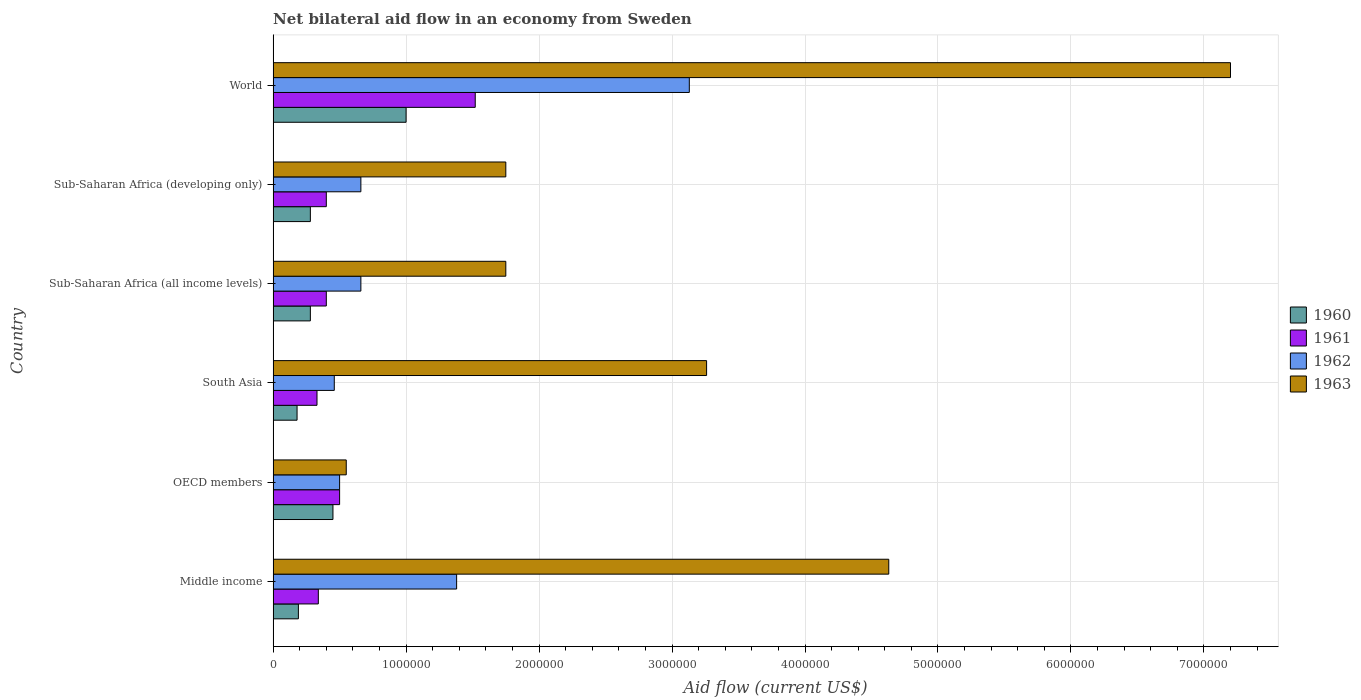How many different coloured bars are there?
Give a very brief answer. 4. How many groups of bars are there?
Give a very brief answer. 6. Are the number of bars per tick equal to the number of legend labels?
Provide a short and direct response. Yes. Are the number of bars on each tick of the Y-axis equal?
Your answer should be compact. Yes. How many bars are there on the 2nd tick from the bottom?
Ensure brevity in your answer.  4. What is the label of the 3rd group of bars from the top?
Keep it short and to the point. Sub-Saharan Africa (all income levels). In how many cases, is the number of bars for a given country not equal to the number of legend labels?
Provide a succinct answer. 0. What is the net bilateral aid flow in 1963 in South Asia?
Ensure brevity in your answer.  3.26e+06. In which country was the net bilateral aid flow in 1962 minimum?
Give a very brief answer. South Asia. What is the total net bilateral aid flow in 1963 in the graph?
Offer a terse response. 1.91e+07. What is the difference between the net bilateral aid flow in 1961 in South Asia and that in World?
Ensure brevity in your answer.  -1.19e+06. What is the difference between the net bilateral aid flow in 1961 in South Asia and the net bilateral aid flow in 1963 in Sub-Saharan Africa (all income levels)?
Offer a terse response. -1.42e+06. What is the average net bilateral aid flow in 1963 per country?
Your answer should be compact. 3.19e+06. What is the difference between the net bilateral aid flow in 1963 and net bilateral aid flow in 1962 in World?
Provide a short and direct response. 4.07e+06. What is the ratio of the net bilateral aid flow in 1960 in Sub-Saharan Africa (developing only) to that in World?
Give a very brief answer. 0.28. Is the net bilateral aid flow in 1960 in OECD members less than that in Sub-Saharan Africa (developing only)?
Your answer should be compact. No. What is the difference between the highest and the second highest net bilateral aid flow in 1963?
Your response must be concise. 2.57e+06. What is the difference between the highest and the lowest net bilateral aid flow in 1962?
Give a very brief answer. 2.67e+06. In how many countries, is the net bilateral aid flow in 1960 greater than the average net bilateral aid flow in 1960 taken over all countries?
Provide a short and direct response. 2. Is the sum of the net bilateral aid flow in 1960 in Sub-Saharan Africa (all income levels) and Sub-Saharan Africa (developing only) greater than the maximum net bilateral aid flow in 1962 across all countries?
Your answer should be compact. No. Is it the case that in every country, the sum of the net bilateral aid flow in 1962 and net bilateral aid flow in 1960 is greater than the sum of net bilateral aid flow in 1961 and net bilateral aid flow in 1963?
Keep it short and to the point. No. What does the 1st bar from the top in World represents?
Keep it short and to the point. 1963. What does the 4th bar from the bottom in South Asia represents?
Offer a very short reply. 1963. Are the values on the major ticks of X-axis written in scientific E-notation?
Ensure brevity in your answer.  No. Where does the legend appear in the graph?
Give a very brief answer. Center right. How many legend labels are there?
Offer a very short reply. 4. What is the title of the graph?
Offer a terse response. Net bilateral aid flow in an economy from Sweden. Does "1996" appear as one of the legend labels in the graph?
Ensure brevity in your answer.  No. What is the label or title of the X-axis?
Give a very brief answer. Aid flow (current US$). What is the Aid flow (current US$) of 1962 in Middle income?
Provide a succinct answer. 1.38e+06. What is the Aid flow (current US$) in 1963 in Middle income?
Offer a very short reply. 4.63e+06. What is the Aid flow (current US$) of 1962 in OECD members?
Your response must be concise. 5.00e+05. What is the Aid flow (current US$) in 1961 in South Asia?
Ensure brevity in your answer.  3.30e+05. What is the Aid flow (current US$) of 1962 in South Asia?
Ensure brevity in your answer.  4.60e+05. What is the Aid flow (current US$) in 1963 in South Asia?
Make the answer very short. 3.26e+06. What is the Aid flow (current US$) of 1962 in Sub-Saharan Africa (all income levels)?
Give a very brief answer. 6.60e+05. What is the Aid flow (current US$) of 1963 in Sub-Saharan Africa (all income levels)?
Keep it short and to the point. 1.75e+06. What is the Aid flow (current US$) of 1961 in Sub-Saharan Africa (developing only)?
Give a very brief answer. 4.00e+05. What is the Aid flow (current US$) of 1962 in Sub-Saharan Africa (developing only)?
Keep it short and to the point. 6.60e+05. What is the Aid flow (current US$) of 1963 in Sub-Saharan Africa (developing only)?
Offer a terse response. 1.75e+06. What is the Aid flow (current US$) in 1961 in World?
Give a very brief answer. 1.52e+06. What is the Aid flow (current US$) in 1962 in World?
Your answer should be compact. 3.13e+06. What is the Aid flow (current US$) in 1963 in World?
Provide a succinct answer. 7.20e+06. Across all countries, what is the maximum Aid flow (current US$) in 1961?
Keep it short and to the point. 1.52e+06. Across all countries, what is the maximum Aid flow (current US$) of 1962?
Ensure brevity in your answer.  3.13e+06. Across all countries, what is the maximum Aid flow (current US$) in 1963?
Offer a terse response. 7.20e+06. Across all countries, what is the minimum Aid flow (current US$) of 1962?
Offer a very short reply. 4.60e+05. Across all countries, what is the minimum Aid flow (current US$) in 1963?
Ensure brevity in your answer.  5.50e+05. What is the total Aid flow (current US$) of 1960 in the graph?
Provide a succinct answer. 2.38e+06. What is the total Aid flow (current US$) of 1961 in the graph?
Provide a short and direct response. 3.49e+06. What is the total Aid flow (current US$) in 1962 in the graph?
Your answer should be compact. 6.79e+06. What is the total Aid flow (current US$) of 1963 in the graph?
Your answer should be compact. 1.91e+07. What is the difference between the Aid flow (current US$) in 1962 in Middle income and that in OECD members?
Keep it short and to the point. 8.80e+05. What is the difference between the Aid flow (current US$) of 1963 in Middle income and that in OECD members?
Provide a succinct answer. 4.08e+06. What is the difference between the Aid flow (current US$) of 1960 in Middle income and that in South Asia?
Ensure brevity in your answer.  10000. What is the difference between the Aid flow (current US$) of 1962 in Middle income and that in South Asia?
Ensure brevity in your answer.  9.20e+05. What is the difference between the Aid flow (current US$) of 1963 in Middle income and that in South Asia?
Ensure brevity in your answer.  1.37e+06. What is the difference between the Aid flow (current US$) in 1960 in Middle income and that in Sub-Saharan Africa (all income levels)?
Keep it short and to the point. -9.00e+04. What is the difference between the Aid flow (current US$) of 1962 in Middle income and that in Sub-Saharan Africa (all income levels)?
Keep it short and to the point. 7.20e+05. What is the difference between the Aid flow (current US$) in 1963 in Middle income and that in Sub-Saharan Africa (all income levels)?
Ensure brevity in your answer.  2.88e+06. What is the difference between the Aid flow (current US$) of 1960 in Middle income and that in Sub-Saharan Africa (developing only)?
Your answer should be very brief. -9.00e+04. What is the difference between the Aid flow (current US$) of 1962 in Middle income and that in Sub-Saharan Africa (developing only)?
Give a very brief answer. 7.20e+05. What is the difference between the Aid flow (current US$) in 1963 in Middle income and that in Sub-Saharan Africa (developing only)?
Offer a very short reply. 2.88e+06. What is the difference between the Aid flow (current US$) of 1960 in Middle income and that in World?
Offer a terse response. -8.10e+05. What is the difference between the Aid flow (current US$) of 1961 in Middle income and that in World?
Your answer should be very brief. -1.18e+06. What is the difference between the Aid flow (current US$) in 1962 in Middle income and that in World?
Your response must be concise. -1.75e+06. What is the difference between the Aid flow (current US$) in 1963 in Middle income and that in World?
Your answer should be very brief. -2.57e+06. What is the difference between the Aid flow (current US$) in 1962 in OECD members and that in South Asia?
Make the answer very short. 4.00e+04. What is the difference between the Aid flow (current US$) in 1963 in OECD members and that in South Asia?
Offer a terse response. -2.71e+06. What is the difference between the Aid flow (current US$) in 1960 in OECD members and that in Sub-Saharan Africa (all income levels)?
Your answer should be compact. 1.70e+05. What is the difference between the Aid flow (current US$) of 1961 in OECD members and that in Sub-Saharan Africa (all income levels)?
Your answer should be compact. 1.00e+05. What is the difference between the Aid flow (current US$) in 1962 in OECD members and that in Sub-Saharan Africa (all income levels)?
Provide a succinct answer. -1.60e+05. What is the difference between the Aid flow (current US$) of 1963 in OECD members and that in Sub-Saharan Africa (all income levels)?
Ensure brevity in your answer.  -1.20e+06. What is the difference between the Aid flow (current US$) of 1962 in OECD members and that in Sub-Saharan Africa (developing only)?
Provide a short and direct response. -1.60e+05. What is the difference between the Aid flow (current US$) of 1963 in OECD members and that in Sub-Saharan Africa (developing only)?
Keep it short and to the point. -1.20e+06. What is the difference between the Aid flow (current US$) in 1960 in OECD members and that in World?
Your answer should be compact. -5.50e+05. What is the difference between the Aid flow (current US$) of 1961 in OECD members and that in World?
Your response must be concise. -1.02e+06. What is the difference between the Aid flow (current US$) of 1962 in OECD members and that in World?
Provide a short and direct response. -2.63e+06. What is the difference between the Aid flow (current US$) of 1963 in OECD members and that in World?
Give a very brief answer. -6.65e+06. What is the difference between the Aid flow (current US$) in 1962 in South Asia and that in Sub-Saharan Africa (all income levels)?
Keep it short and to the point. -2.00e+05. What is the difference between the Aid flow (current US$) in 1963 in South Asia and that in Sub-Saharan Africa (all income levels)?
Keep it short and to the point. 1.51e+06. What is the difference between the Aid flow (current US$) in 1960 in South Asia and that in Sub-Saharan Africa (developing only)?
Provide a short and direct response. -1.00e+05. What is the difference between the Aid flow (current US$) of 1962 in South Asia and that in Sub-Saharan Africa (developing only)?
Your answer should be compact. -2.00e+05. What is the difference between the Aid flow (current US$) in 1963 in South Asia and that in Sub-Saharan Africa (developing only)?
Keep it short and to the point. 1.51e+06. What is the difference between the Aid flow (current US$) of 1960 in South Asia and that in World?
Your answer should be very brief. -8.20e+05. What is the difference between the Aid flow (current US$) of 1961 in South Asia and that in World?
Provide a short and direct response. -1.19e+06. What is the difference between the Aid flow (current US$) of 1962 in South Asia and that in World?
Offer a terse response. -2.67e+06. What is the difference between the Aid flow (current US$) of 1963 in South Asia and that in World?
Your answer should be compact. -3.94e+06. What is the difference between the Aid flow (current US$) of 1962 in Sub-Saharan Africa (all income levels) and that in Sub-Saharan Africa (developing only)?
Provide a succinct answer. 0. What is the difference between the Aid flow (current US$) of 1960 in Sub-Saharan Africa (all income levels) and that in World?
Provide a succinct answer. -7.20e+05. What is the difference between the Aid flow (current US$) of 1961 in Sub-Saharan Africa (all income levels) and that in World?
Your answer should be very brief. -1.12e+06. What is the difference between the Aid flow (current US$) of 1962 in Sub-Saharan Africa (all income levels) and that in World?
Offer a very short reply. -2.47e+06. What is the difference between the Aid flow (current US$) in 1963 in Sub-Saharan Africa (all income levels) and that in World?
Ensure brevity in your answer.  -5.45e+06. What is the difference between the Aid flow (current US$) of 1960 in Sub-Saharan Africa (developing only) and that in World?
Offer a very short reply. -7.20e+05. What is the difference between the Aid flow (current US$) in 1961 in Sub-Saharan Africa (developing only) and that in World?
Make the answer very short. -1.12e+06. What is the difference between the Aid flow (current US$) in 1962 in Sub-Saharan Africa (developing only) and that in World?
Make the answer very short. -2.47e+06. What is the difference between the Aid flow (current US$) of 1963 in Sub-Saharan Africa (developing only) and that in World?
Your response must be concise. -5.45e+06. What is the difference between the Aid flow (current US$) in 1960 in Middle income and the Aid flow (current US$) in 1961 in OECD members?
Your response must be concise. -3.10e+05. What is the difference between the Aid flow (current US$) in 1960 in Middle income and the Aid flow (current US$) in 1962 in OECD members?
Give a very brief answer. -3.10e+05. What is the difference between the Aid flow (current US$) of 1960 in Middle income and the Aid flow (current US$) of 1963 in OECD members?
Ensure brevity in your answer.  -3.60e+05. What is the difference between the Aid flow (current US$) in 1961 in Middle income and the Aid flow (current US$) in 1963 in OECD members?
Your response must be concise. -2.10e+05. What is the difference between the Aid flow (current US$) of 1962 in Middle income and the Aid flow (current US$) of 1963 in OECD members?
Make the answer very short. 8.30e+05. What is the difference between the Aid flow (current US$) in 1960 in Middle income and the Aid flow (current US$) in 1961 in South Asia?
Provide a succinct answer. -1.40e+05. What is the difference between the Aid flow (current US$) of 1960 in Middle income and the Aid flow (current US$) of 1963 in South Asia?
Ensure brevity in your answer.  -3.07e+06. What is the difference between the Aid flow (current US$) in 1961 in Middle income and the Aid flow (current US$) in 1962 in South Asia?
Make the answer very short. -1.20e+05. What is the difference between the Aid flow (current US$) of 1961 in Middle income and the Aid flow (current US$) of 1963 in South Asia?
Provide a succinct answer. -2.92e+06. What is the difference between the Aid flow (current US$) of 1962 in Middle income and the Aid flow (current US$) of 1963 in South Asia?
Offer a very short reply. -1.88e+06. What is the difference between the Aid flow (current US$) in 1960 in Middle income and the Aid flow (current US$) in 1962 in Sub-Saharan Africa (all income levels)?
Your answer should be compact. -4.70e+05. What is the difference between the Aid flow (current US$) of 1960 in Middle income and the Aid flow (current US$) of 1963 in Sub-Saharan Africa (all income levels)?
Give a very brief answer. -1.56e+06. What is the difference between the Aid flow (current US$) in 1961 in Middle income and the Aid flow (current US$) in 1962 in Sub-Saharan Africa (all income levels)?
Ensure brevity in your answer.  -3.20e+05. What is the difference between the Aid flow (current US$) of 1961 in Middle income and the Aid flow (current US$) of 1963 in Sub-Saharan Africa (all income levels)?
Your response must be concise. -1.41e+06. What is the difference between the Aid flow (current US$) of 1962 in Middle income and the Aid flow (current US$) of 1963 in Sub-Saharan Africa (all income levels)?
Ensure brevity in your answer.  -3.70e+05. What is the difference between the Aid flow (current US$) of 1960 in Middle income and the Aid flow (current US$) of 1961 in Sub-Saharan Africa (developing only)?
Your response must be concise. -2.10e+05. What is the difference between the Aid flow (current US$) of 1960 in Middle income and the Aid flow (current US$) of 1962 in Sub-Saharan Africa (developing only)?
Keep it short and to the point. -4.70e+05. What is the difference between the Aid flow (current US$) in 1960 in Middle income and the Aid flow (current US$) in 1963 in Sub-Saharan Africa (developing only)?
Provide a short and direct response. -1.56e+06. What is the difference between the Aid flow (current US$) of 1961 in Middle income and the Aid flow (current US$) of 1962 in Sub-Saharan Africa (developing only)?
Keep it short and to the point. -3.20e+05. What is the difference between the Aid flow (current US$) of 1961 in Middle income and the Aid flow (current US$) of 1963 in Sub-Saharan Africa (developing only)?
Your response must be concise. -1.41e+06. What is the difference between the Aid flow (current US$) in 1962 in Middle income and the Aid flow (current US$) in 1963 in Sub-Saharan Africa (developing only)?
Your response must be concise. -3.70e+05. What is the difference between the Aid flow (current US$) of 1960 in Middle income and the Aid flow (current US$) of 1961 in World?
Your answer should be very brief. -1.33e+06. What is the difference between the Aid flow (current US$) of 1960 in Middle income and the Aid flow (current US$) of 1962 in World?
Provide a succinct answer. -2.94e+06. What is the difference between the Aid flow (current US$) of 1960 in Middle income and the Aid flow (current US$) of 1963 in World?
Provide a succinct answer. -7.01e+06. What is the difference between the Aid flow (current US$) of 1961 in Middle income and the Aid flow (current US$) of 1962 in World?
Provide a short and direct response. -2.79e+06. What is the difference between the Aid flow (current US$) of 1961 in Middle income and the Aid flow (current US$) of 1963 in World?
Ensure brevity in your answer.  -6.86e+06. What is the difference between the Aid flow (current US$) of 1962 in Middle income and the Aid flow (current US$) of 1963 in World?
Offer a terse response. -5.82e+06. What is the difference between the Aid flow (current US$) in 1960 in OECD members and the Aid flow (current US$) in 1961 in South Asia?
Your answer should be very brief. 1.20e+05. What is the difference between the Aid flow (current US$) of 1960 in OECD members and the Aid flow (current US$) of 1962 in South Asia?
Provide a short and direct response. -10000. What is the difference between the Aid flow (current US$) of 1960 in OECD members and the Aid flow (current US$) of 1963 in South Asia?
Give a very brief answer. -2.81e+06. What is the difference between the Aid flow (current US$) of 1961 in OECD members and the Aid flow (current US$) of 1962 in South Asia?
Your response must be concise. 4.00e+04. What is the difference between the Aid flow (current US$) of 1961 in OECD members and the Aid flow (current US$) of 1963 in South Asia?
Ensure brevity in your answer.  -2.76e+06. What is the difference between the Aid flow (current US$) of 1962 in OECD members and the Aid flow (current US$) of 1963 in South Asia?
Your response must be concise. -2.76e+06. What is the difference between the Aid flow (current US$) in 1960 in OECD members and the Aid flow (current US$) in 1961 in Sub-Saharan Africa (all income levels)?
Provide a short and direct response. 5.00e+04. What is the difference between the Aid flow (current US$) of 1960 in OECD members and the Aid flow (current US$) of 1963 in Sub-Saharan Africa (all income levels)?
Provide a short and direct response. -1.30e+06. What is the difference between the Aid flow (current US$) of 1961 in OECD members and the Aid flow (current US$) of 1963 in Sub-Saharan Africa (all income levels)?
Offer a very short reply. -1.25e+06. What is the difference between the Aid flow (current US$) of 1962 in OECD members and the Aid flow (current US$) of 1963 in Sub-Saharan Africa (all income levels)?
Provide a succinct answer. -1.25e+06. What is the difference between the Aid flow (current US$) of 1960 in OECD members and the Aid flow (current US$) of 1961 in Sub-Saharan Africa (developing only)?
Keep it short and to the point. 5.00e+04. What is the difference between the Aid flow (current US$) in 1960 in OECD members and the Aid flow (current US$) in 1963 in Sub-Saharan Africa (developing only)?
Offer a terse response. -1.30e+06. What is the difference between the Aid flow (current US$) in 1961 in OECD members and the Aid flow (current US$) in 1962 in Sub-Saharan Africa (developing only)?
Your answer should be compact. -1.60e+05. What is the difference between the Aid flow (current US$) in 1961 in OECD members and the Aid flow (current US$) in 1963 in Sub-Saharan Africa (developing only)?
Provide a succinct answer. -1.25e+06. What is the difference between the Aid flow (current US$) of 1962 in OECD members and the Aid flow (current US$) of 1963 in Sub-Saharan Africa (developing only)?
Your answer should be compact. -1.25e+06. What is the difference between the Aid flow (current US$) in 1960 in OECD members and the Aid flow (current US$) in 1961 in World?
Offer a very short reply. -1.07e+06. What is the difference between the Aid flow (current US$) of 1960 in OECD members and the Aid flow (current US$) of 1962 in World?
Your answer should be compact. -2.68e+06. What is the difference between the Aid flow (current US$) in 1960 in OECD members and the Aid flow (current US$) in 1963 in World?
Ensure brevity in your answer.  -6.75e+06. What is the difference between the Aid flow (current US$) in 1961 in OECD members and the Aid flow (current US$) in 1962 in World?
Give a very brief answer. -2.63e+06. What is the difference between the Aid flow (current US$) in 1961 in OECD members and the Aid flow (current US$) in 1963 in World?
Offer a very short reply. -6.70e+06. What is the difference between the Aid flow (current US$) in 1962 in OECD members and the Aid flow (current US$) in 1963 in World?
Your answer should be compact. -6.70e+06. What is the difference between the Aid flow (current US$) in 1960 in South Asia and the Aid flow (current US$) in 1962 in Sub-Saharan Africa (all income levels)?
Your response must be concise. -4.80e+05. What is the difference between the Aid flow (current US$) of 1960 in South Asia and the Aid flow (current US$) of 1963 in Sub-Saharan Africa (all income levels)?
Provide a short and direct response. -1.57e+06. What is the difference between the Aid flow (current US$) of 1961 in South Asia and the Aid flow (current US$) of 1962 in Sub-Saharan Africa (all income levels)?
Your answer should be very brief. -3.30e+05. What is the difference between the Aid flow (current US$) in 1961 in South Asia and the Aid flow (current US$) in 1963 in Sub-Saharan Africa (all income levels)?
Offer a terse response. -1.42e+06. What is the difference between the Aid flow (current US$) in 1962 in South Asia and the Aid flow (current US$) in 1963 in Sub-Saharan Africa (all income levels)?
Your response must be concise. -1.29e+06. What is the difference between the Aid flow (current US$) of 1960 in South Asia and the Aid flow (current US$) of 1962 in Sub-Saharan Africa (developing only)?
Your response must be concise. -4.80e+05. What is the difference between the Aid flow (current US$) of 1960 in South Asia and the Aid flow (current US$) of 1963 in Sub-Saharan Africa (developing only)?
Ensure brevity in your answer.  -1.57e+06. What is the difference between the Aid flow (current US$) in 1961 in South Asia and the Aid flow (current US$) in 1962 in Sub-Saharan Africa (developing only)?
Make the answer very short. -3.30e+05. What is the difference between the Aid flow (current US$) in 1961 in South Asia and the Aid flow (current US$) in 1963 in Sub-Saharan Africa (developing only)?
Your answer should be compact. -1.42e+06. What is the difference between the Aid flow (current US$) in 1962 in South Asia and the Aid flow (current US$) in 1963 in Sub-Saharan Africa (developing only)?
Offer a very short reply. -1.29e+06. What is the difference between the Aid flow (current US$) of 1960 in South Asia and the Aid flow (current US$) of 1961 in World?
Your answer should be very brief. -1.34e+06. What is the difference between the Aid flow (current US$) of 1960 in South Asia and the Aid flow (current US$) of 1962 in World?
Ensure brevity in your answer.  -2.95e+06. What is the difference between the Aid flow (current US$) in 1960 in South Asia and the Aid flow (current US$) in 1963 in World?
Provide a succinct answer. -7.02e+06. What is the difference between the Aid flow (current US$) of 1961 in South Asia and the Aid flow (current US$) of 1962 in World?
Your answer should be compact. -2.80e+06. What is the difference between the Aid flow (current US$) of 1961 in South Asia and the Aid flow (current US$) of 1963 in World?
Your response must be concise. -6.87e+06. What is the difference between the Aid flow (current US$) in 1962 in South Asia and the Aid flow (current US$) in 1963 in World?
Provide a short and direct response. -6.74e+06. What is the difference between the Aid flow (current US$) of 1960 in Sub-Saharan Africa (all income levels) and the Aid flow (current US$) of 1961 in Sub-Saharan Africa (developing only)?
Make the answer very short. -1.20e+05. What is the difference between the Aid flow (current US$) of 1960 in Sub-Saharan Africa (all income levels) and the Aid flow (current US$) of 1962 in Sub-Saharan Africa (developing only)?
Make the answer very short. -3.80e+05. What is the difference between the Aid flow (current US$) in 1960 in Sub-Saharan Africa (all income levels) and the Aid flow (current US$) in 1963 in Sub-Saharan Africa (developing only)?
Your answer should be very brief. -1.47e+06. What is the difference between the Aid flow (current US$) of 1961 in Sub-Saharan Africa (all income levels) and the Aid flow (current US$) of 1962 in Sub-Saharan Africa (developing only)?
Your answer should be compact. -2.60e+05. What is the difference between the Aid flow (current US$) of 1961 in Sub-Saharan Africa (all income levels) and the Aid flow (current US$) of 1963 in Sub-Saharan Africa (developing only)?
Offer a very short reply. -1.35e+06. What is the difference between the Aid flow (current US$) in 1962 in Sub-Saharan Africa (all income levels) and the Aid flow (current US$) in 1963 in Sub-Saharan Africa (developing only)?
Offer a very short reply. -1.09e+06. What is the difference between the Aid flow (current US$) of 1960 in Sub-Saharan Africa (all income levels) and the Aid flow (current US$) of 1961 in World?
Your answer should be very brief. -1.24e+06. What is the difference between the Aid flow (current US$) of 1960 in Sub-Saharan Africa (all income levels) and the Aid flow (current US$) of 1962 in World?
Ensure brevity in your answer.  -2.85e+06. What is the difference between the Aid flow (current US$) of 1960 in Sub-Saharan Africa (all income levels) and the Aid flow (current US$) of 1963 in World?
Your answer should be compact. -6.92e+06. What is the difference between the Aid flow (current US$) of 1961 in Sub-Saharan Africa (all income levels) and the Aid flow (current US$) of 1962 in World?
Your response must be concise. -2.73e+06. What is the difference between the Aid flow (current US$) of 1961 in Sub-Saharan Africa (all income levels) and the Aid flow (current US$) of 1963 in World?
Provide a short and direct response. -6.80e+06. What is the difference between the Aid flow (current US$) in 1962 in Sub-Saharan Africa (all income levels) and the Aid flow (current US$) in 1963 in World?
Ensure brevity in your answer.  -6.54e+06. What is the difference between the Aid flow (current US$) of 1960 in Sub-Saharan Africa (developing only) and the Aid flow (current US$) of 1961 in World?
Provide a short and direct response. -1.24e+06. What is the difference between the Aid flow (current US$) of 1960 in Sub-Saharan Africa (developing only) and the Aid flow (current US$) of 1962 in World?
Your response must be concise. -2.85e+06. What is the difference between the Aid flow (current US$) of 1960 in Sub-Saharan Africa (developing only) and the Aid flow (current US$) of 1963 in World?
Make the answer very short. -6.92e+06. What is the difference between the Aid flow (current US$) of 1961 in Sub-Saharan Africa (developing only) and the Aid flow (current US$) of 1962 in World?
Your answer should be compact. -2.73e+06. What is the difference between the Aid flow (current US$) in 1961 in Sub-Saharan Africa (developing only) and the Aid flow (current US$) in 1963 in World?
Make the answer very short. -6.80e+06. What is the difference between the Aid flow (current US$) in 1962 in Sub-Saharan Africa (developing only) and the Aid flow (current US$) in 1963 in World?
Your answer should be very brief. -6.54e+06. What is the average Aid flow (current US$) in 1960 per country?
Ensure brevity in your answer.  3.97e+05. What is the average Aid flow (current US$) of 1961 per country?
Your answer should be very brief. 5.82e+05. What is the average Aid flow (current US$) in 1962 per country?
Provide a short and direct response. 1.13e+06. What is the average Aid flow (current US$) of 1963 per country?
Your answer should be compact. 3.19e+06. What is the difference between the Aid flow (current US$) in 1960 and Aid flow (current US$) in 1961 in Middle income?
Provide a short and direct response. -1.50e+05. What is the difference between the Aid flow (current US$) of 1960 and Aid flow (current US$) of 1962 in Middle income?
Provide a succinct answer. -1.19e+06. What is the difference between the Aid flow (current US$) in 1960 and Aid flow (current US$) in 1963 in Middle income?
Provide a short and direct response. -4.44e+06. What is the difference between the Aid flow (current US$) of 1961 and Aid flow (current US$) of 1962 in Middle income?
Give a very brief answer. -1.04e+06. What is the difference between the Aid flow (current US$) in 1961 and Aid flow (current US$) in 1963 in Middle income?
Offer a very short reply. -4.29e+06. What is the difference between the Aid flow (current US$) in 1962 and Aid flow (current US$) in 1963 in Middle income?
Offer a very short reply. -3.25e+06. What is the difference between the Aid flow (current US$) in 1960 and Aid flow (current US$) in 1962 in OECD members?
Give a very brief answer. -5.00e+04. What is the difference between the Aid flow (current US$) of 1960 and Aid flow (current US$) of 1963 in OECD members?
Give a very brief answer. -1.00e+05. What is the difference between the Aid flow (current US$) of 1960 and Aid flow (current US$) of 1961 in South Asia?
Your answer should be very brief. -1.50e+05. What is the difference between the Aid flow (current US$) in 1960 and Aid flow (current US$) in 1962 in South Asia?
Keep it short and to the point. -2.80e+05. What is the difference between the Aid flow (current US$) in 1960 and Aid flow (current US$) in 1963 in South Asia?
Your response must be concise. -3.08e+06. What is the difference between the Aid flow (current US$) in 1961 and Aid flow (current US$) in 1963 in South Asia?
Offer a terse response. -2.93e+06. What is the difference between the Aid flow (current US$) of 1962 and Aid flow (current US$) of 1963 in South Asia?
Offer a very short reply. -2.80e+06. What is the difference between the Aid flow (current US$) of 1960 and Aid flow (current US$) of 1961 in Sub-Saharan Africa (all income levels)?
Give a very brief answer. -1.20e+05. What is the difference between the Aid flow (current US$) of 1960 and Aid flow (current US$) of 1962 in Sub-Saharan Africa (all income levels)?
Offer a very short reply. -3.80e+05. What is the difference between the Aid flow (current US$) of 1960 and Aid flow (current US$) of 1963 in Sub-Saharan Africa (all income levels)?
Ensure brevity in your answer.  -1.47e+06. What is the difference between the Aid flow (current US$) of 1961 and Aid flow (current US$) of 1963 in Sub-Saharan Africa (all income levels)?
Make the answer very short. -1.35e+06. What is the difference between the Aid flow (current US$) in 1962 and Aid flow (current US$) in 1963 in Sub-Saharan Africa (all income levels)?
Offer a terse response. -1.09e+06. What is the difference between the Aid flow (current US$) in 1960 and Aid flow (current US$) in 1961 in Sub-Saharan Africa (developing only)?
Your answer should be compact. -1.20e+05. What is the difference between the Aid flow (current US$) in 1960 and Aid flow (current US$) in 1962 in Sub-Saharan Africa (developing only)?
Offer a very short reply. -3.80e+05. What is the difference between the Aid flow (current US$) of 1960 and Aid flow (current US$) of 1963 in Sub-Saharan Africa (developing only)?
Keep it short and to the point. -1.47e+06. What is the difference between the Aid flow (current US$) of 1961 and Aid flow (current US$) of 1963 in Sub-Saharan Africa (developing only)?
Give a very brief answer. -1.35e+06. What is the difference between the Aid flow (current US$) in 1962 and Aid flow (current US$) in 1963 in Sub-Saharan Africa (developing only)?
Make the answer very short. -1.09e+06. What is the difference between the Aid flow (current US$) in 1960 and Aid flow (current US$) in 1961 in World?
Make the answer very short. -5.20e+05. What is the difference between the Aid flow (current US$) in 1960 and Aid flow (current US$) in 1962 in World?
Make the answer very short. -2.13e+06. What is the difference between the Aid flow (current US$) of 1960 and Aid flow (current US$) of 1963 in World?
Your response must be concise. -6.20e+06. What is the difference between the Aid flow (current US$) in 1961 and Aid flow (current US$) in 1962 in World?
Keep it short and to the point. -1.61e+06. What is the difference between the Aid flow (current US$) of 1961 and Aid flow (current US$) of 1963 in World?
Your answer should be very brief. -5.68e+06. What is the difference between the Aid flow (current US$) of 1962 and Aid flow (current US$) of 1963 in World?
Give a very brief answer. -4.07e+06. What is the ratio of the Aid flow (current US$) in 1960 in Middle income to that in OECD members?
Offer a terse response. 0.42. What is the ratio of the Aid flow (current US$) in 1961 in Middle income to that in OECD members?
Give a very brief answer. 0.68. What is the ratio of the Aid flow (current US$) in 1962 in Middle income to that in OECD members?
Provide a short and direct response. 2.76. What is the ratio of the Aid flow (current US$) of 1963 in Middle income to that in OECD members?
Provide a short and direct response. 8.42. What is the ratio of the Aid flow (current US$) in 1960 in Middle income to that in South Asia?
Ensure brevity in your answer.  1.06. What is the ratio of the Aid flow (current US$) of 1961 in Middle income to that in South Asia?
Provide a succinct answer. 1.03. What is the ratio of the Aid flow (current US$) of 1963 in Middle income to that in South Asia?
Offer a very short reply. 1.42. What is the ratio of the Aid flow (current US$) of 1960 in Middle income to that in Sub-Saharan Africa (all income levels)?
Give a very brief answer. 0.68. What is the ratio of the Aid flow (current US$) of 1962 in Middle income to that in Sub-Saharan Africa (all income levels)?
Provide a succinct answer. 2.09. What is the ratio of the Aid flow (current US$) in 1963 in Middle income to that in Sub-Saharan Africa (all income levels)?
Ensure brevity in your answer.  2.65. What is the ratio of the Aid flow (current US$) of 1960 in Middle income to that in Sub-Saharan Africa (developing only)?
Offer a very short reply. 0.68. What is the ratio of the Aid flow (current US$) in 1962 in Middle income to that in Sub-Saharan Africa (developing only)?
Provide a short and direct response. 2.09. What is the ratio of the Aid flow (current US$) of 1963 in Middle income to that in Sub-Saharan Africa (developing only)?
Give a very brief answer. 2.65. What is the ratio of the Aid flow (current US$) of 1960 in Middle income to that in World?
Your response must be concise. 0.19. What is the ratio of the Aid flow (current US$) in 1961 in Middle income to that in World?
Offer a very short reply. 0.22. What is the ratio of the Aid flow (current US$) in 1962 in Middle income to that in World?
Your answer should be compact. 0.44. What is the ratio of the Aid flow (current US$) in 1963 in Middle income to that in World?
Your answer should be compact. 0.64. What is the ratio of the Aid flow (current US$) of 1961 in OECD members to that in South Asia?
Make the answer very short. 1.52. What is the ratio of the Aid flow (current US$) of 1962 in OECD members to that in South Asia?
Your answer should be very brief. 1.09. What is the ratio of the Aid flow (current US$) in 1963 in OECD members to that in South Asia?
Offer a very short reply. 0.17. What is the ratio of the Aid flow (current US$) of 1960 in OECD members to that in Sub-Saharan Africa (all income levels)?
Provide a short and direct response. 1.61. What is the ratio of the Aid flow (current US$) in 1962 in OECD members to that in Sub-Saharan Africa (all income levels)?
Offer a terse response. 0.76. What is the ratio of the Aid flow (current US$) in 1963 in OECD members to that in Sub-Saharan Africa (all income levels)?
Offer a very short reply. 0.31. What is the ratio of the Aid flow (current US$) of 1960 in OECD members to that in Sub-Saharan Africa (developing only)?
Offer a very short reply. 1.61. What is the ratio of the Aid flow (current US$) of 1962 in OECD members to that in Sub-Saharan Africa (developing only)?
Provide a succinct answer. 0.76. What is the ratio of the Aid flow (current US$) of 1963 in OECD members to that in Sub-Saharan Africa (developing only)?
Ensure brevity in your answer.  0.31. What is the ratio of the Aid flow (current US$) in 1960 in OECD members to that in World?
Your answer should be compact. 0.45. What is the ratio of the Aid flow (current US$) of 1961 in OECD members to that in World?
Keep it short and to the point. 0.33. What is the ratio of the Aid flow (current US$) in 1962 in OECD members to that in World?
Offer a very short reply. 0.16. What is the ratio of the Aid flow (current US$) in 1963 in OECD members to that in World?
Offer a terse response. 0.08. What is the ratio of the Aid flow (current US$) of 1960 in South Asia to that in Sub-Saharan Africa (all income levels)?
Keep it short and to the point. 0.64. What is the ratio of the Aid flow (current US$) of 1961 in South Asia to that in Sub-Saharan Africa (all income levels)?
Offer a very short reply. 0.82. What is the ratio of the Aid flow (current US$) in 1962 in South Asia to that in Sub-Saharan Africa (all income levels)?
Your answer should be very brief. 0.7. What is the ratio of the Aid flow (current US$) of 1963 in South Asia to that in Sub-Saharan Africa (all income levels)?
Give a very brief answer. 1.86. What is the ratio of the Aid flow (current US$) in 1960 in South Asia to that in Sub-Saharan Africa (developing only)?
Your answer should be very brief. 0.64. What is the ratio of the Aid flow (current US$) in 1961 in South Asia to that in Sub-Saharan Africa (developing only)?
Provide a succinct answer. 0.82. What is the ratio of the Aid flow (current US$) in 1962 in South Asia to that in Sub-Saharan Africa (developing only)?
Offer a terse response. 0.7. What is the ratio of the Aid flow (current US$) in 1963 in South Asia to that in Sub-Saharan Africa (developing only)?
Offer a terse response. 1.86. What is the ratio of the Aid flow (current US$) in 1960 in South Asia to that in World?
Provide a succinct answer. 0.18. What is the ratio of the Aid flow (current US$) in 1961 in South Asia to that in World?
Your response must be concise. 0.22. What is the ratio of the Aid flow (current US$) in 1962 in South Asia to that in World?
Offer a very short reply. 0.15. What is the ratio of the Aid flow (current US$) in 1963 in South Asia to that in World?
Provide a short and direct response. 0.45. What is the ratio of the Aid flow (current US$) of 1961 in Sub-Saharan Africa (all income levels) to that in Sub-Saharan Africa (developing only)?
Offer a terse response. 1. What is the ratio of the Aid flow (current US$) of 1960 in Sub-Saharan Africa (all income levels) to that in World?
Offer a terse response. 0.28. What is the ratio of the Aid flow (current US$) in 1961 in Sub-Saharan Africa (all income levels) to that in World?
Your answer should be very brief. 0.26. What is the ratio of the Aid flow (current US$) in 1962 in Sub-Saharan Africa (all income levels) to that in World?
Provide a short and direct response. 0.21. What is the ratio of the Aid flow (current US$) of 1963 in Sub-Saharan Africa (all income levels) to that in World?
Offer a terse response. 0.24. What is the ratio of the Aid flow (current US$) in 1960 in Sub-Saharan Africa (developing only) to that in World?
Your answer should be compact. 0.28. What is the ratio of the Aid flow (current US$) in 1961 in Sub-Saharan Africa (developing only) to that in World?
Offer a terse response. 0.26. What is the ratio of the Aid flow (current US$) in 1962 in Sub-Saharan Africa (developing only) to that in World?
Make the answer very short. 0.21. What is the ratio of the Aid flow (current US$) in 1963 in Sub-Saharan Africa (developing only) to that in World?
Provide a short and direct response. 0.24. What is the difference between the highest and the second highest Aid flow (current US$) in 1961?
Give a very brief answer. 1.02e+06. What is the difference between the highest and the second highest Aid flow (current US$) of 1962?
Your answer should be compact. 1.75e+06. What is the difference between the highest and the second highest Aid flow (current US$) in 1963?
Provide a short and direct response. 2.57e+06. What is the difference between the highest and the lowest Aid flow (current US$) in 1960?
Provide a succinct answer. 8.20e+05. What is the difference between the highest and the lowest Aid flow (current US$) in 1961?
Provide a short and direct response. 1.19e+06. What is the difference between the highest and the lowest Aid flow (current US$) of 1962?
Keep it short and to the point. 2.67e+06. What is the difference between the highest and the lowest Aid flow (current US$) of 1963?
Provide a short and direct response. 6.65e+06. 